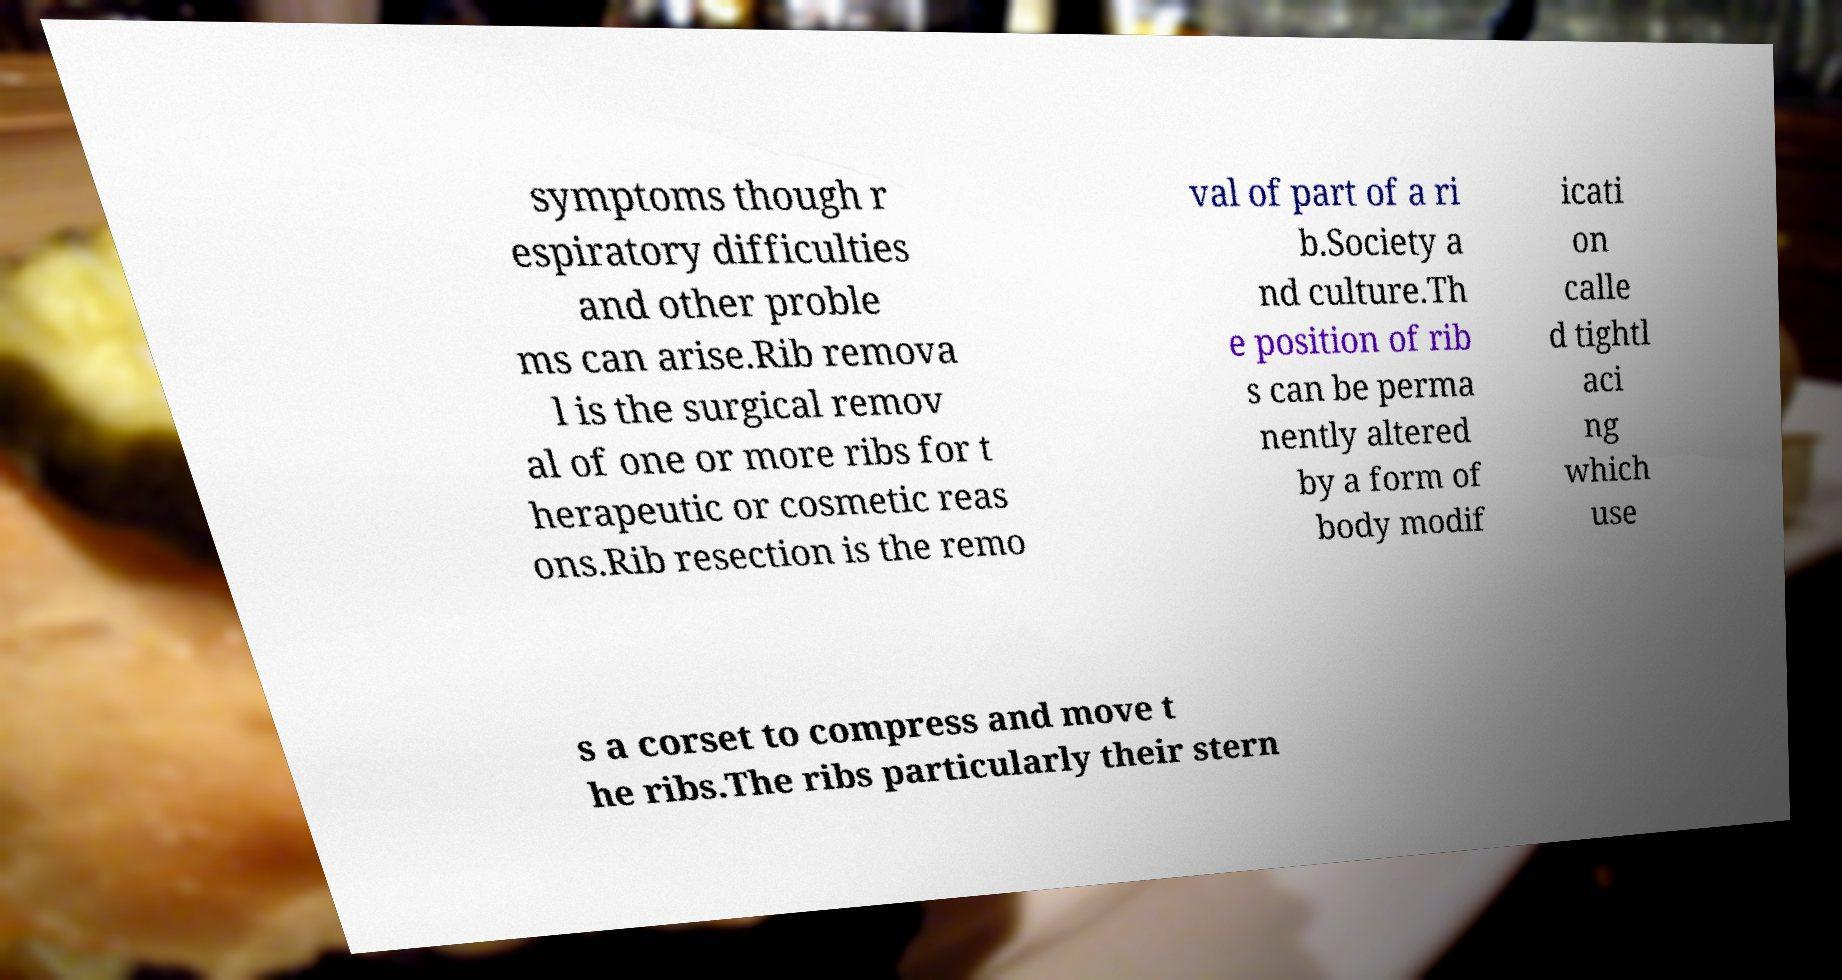Please read and relay the text visible in this image. What does it say? symptoms though r espiratory difficulties and other proble ms can arise.Rib remova l is the surgical remov al of one or more ribs for t herapeutic or cosmetic reas ons.Rib resection is the remo val of part of a ri b.Society a nd culture.Th e position of rib s can be perma nently altered by a form of body modif icati on calle d tightl aci ng which use s a corset to compress and move t he ribs.The ribs particularly their stern 